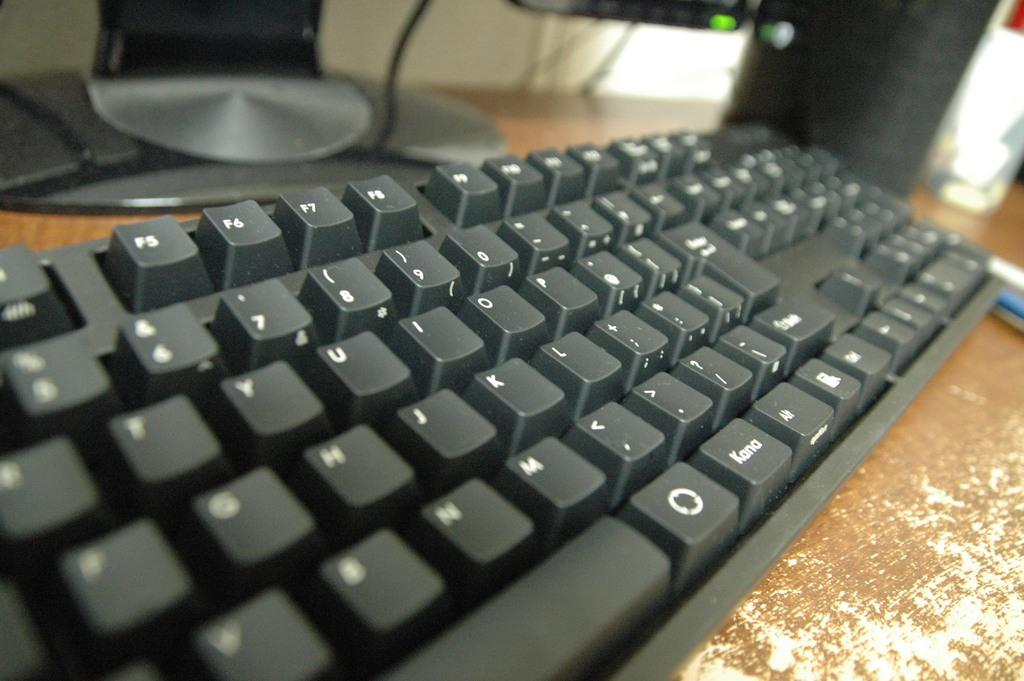<image>
Present a compact description of the photo's key features. A black keyboard with the numbers and letters all written in white. 